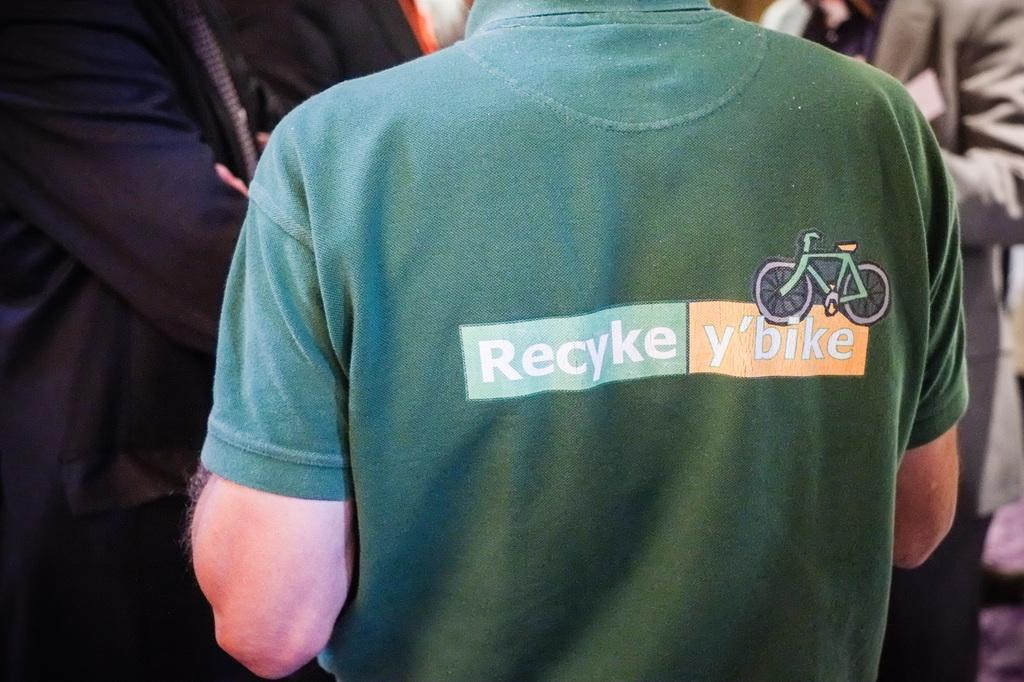What are the two persons in the image wearing? One person is wearing a green t-shirt, and the other person is wearing a black dress. What are the positions of the two persons in the image? Both persons are standing. Can you describe the background of the image? There are other persons visible in the background of the image. What type of quartz can be seen in the hands of the person wearing the green t-shirt? There is no quartz present in the image; the person wearing the green t-shirt is not holding any quartz. How many ants are visible on the person wearing the black dress? There are no ants visible on the person wearing the black dress, as ants are not present in the image. 